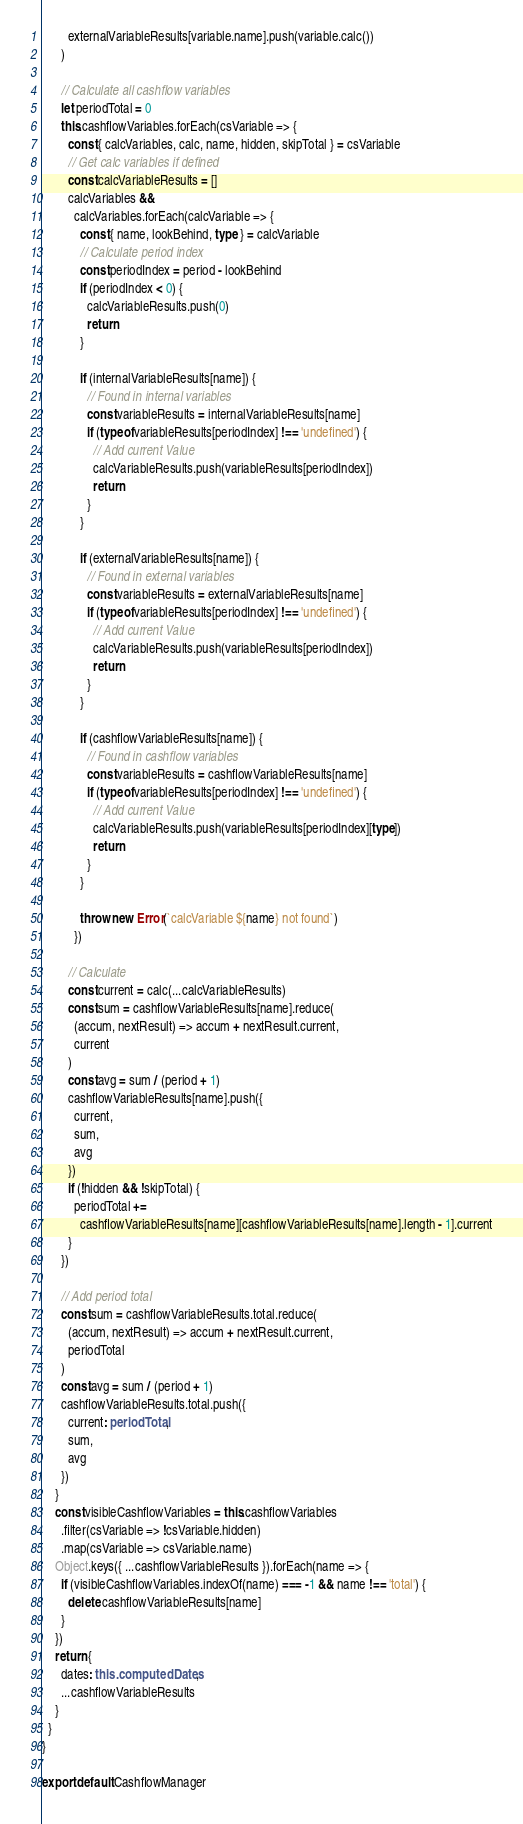<code> <loc_0><loc_0><loc_500><loc_500><_TypeScript_>        externalVariableResults[variable.name].push(variable.calc())
      )

      // Calculate all cashflow variables
      let periodTotal = 0
      this.cashflowVariables.forEach(csVariable => {
        const { calcVariables, calc, name, hidden, skipTotal } = csVariable
        // Get calc variables if defined
        const calcVariableResults = []
        calcVariables &&
          calcVariables.forEach(calcVariable => {
            const { name, lookBehind, type } = calcVariable
            // Calculate period index
            const periodIndex = period - lookBehind
            if (periodIndex < 0) {
              calcVariableResults.push(0)
              return
            }

            if (internalVariableResults[name]) {
              // Found in internal variables
              const variableResults = internalVariableResults[name]
              if (typeof variableResults[periodIndex] !== 'undefined') {
                // Add current Value
                calcVariableResults.push(variableResults[periodIndex])
                return
              }
            }

            if (externalVariableResults[name]) {
              // Found in external variables
              const variableResults = externalVariableResults[name]
              if (typeof variableResults[periodIndex] !== 'undefined') {
                // Add current Value
                calcVariableResults.push(variableResults[periodIndex])
                return
              }
            }

            if (cashflowVariableResults[name]) {
              // Found in cashflow variables
              const variableResults = cashflowVariableResults[name]
              if (typeof variableResults[periodIndex] !== 'undefined') {
                // Add current Value
                calcVariableResults.push(variableResults[periodIndex][type])
                return
              }
            }

            throw new Error(`calcVariable ${name} not found`)
          })

        // Calculate
        const current = calc(...calcVariableResults)
        const sum = cashflowVariableResults[name].reduce(
          (accum, nextResult) => accum + nextResult.current,
          current
        )
        const avg = sum / (period + 1)
        cashflowVariableResults[name].push({
          current,
          sum,
          avg
        })
        if (!hidden && !skipTotal) {
          periodTotal +=
            cashflowVariableResults[name][cashflowVariableResults[name].length - 1].current
        }
      })

      // Add period total
      const sum = cashflowVariableResults.total.reduce(
        (accum, nextResult) => accum + nextResult.current,
        periodTotal
      )
      const avg = sum / (period + 1)
      cashflowVariableResults.total.push({
        current: periodTotal,
        sum,
        avg
      })
    }
    const visibleCashflowVariables = this.cashflowVariables
      .filter(csVariable => !csVariable.hidden)
      .map(csVariable => csVariable.name)
    Object.keys({ ...cashflowVariableResults }).forEach(name => {
      if (visibleCashflowVariables.indexOf(name) === -1 && name !== 'total') {
        delete cashflowVariableResults[name]
      }
    })
    return {
      dates: this.computedDates,
      ...cashflowVariableResults
    }
  }
}

export default CashflowManager
</code> 